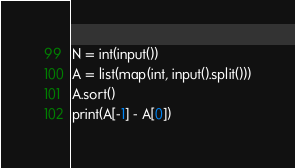<code> <loc_0><loc_0><loc_500><loc_500><_Python_>N = int(input())
A = list(map(int, input().split()))
A.sort()
print(A[-1] - A[0])</code> 